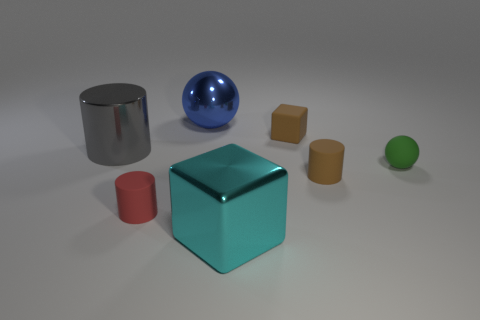How many other objects are the same size as the metallic cylinder?
Keep it short and to the point. 2. There is a tiny cylinder on the left side of the large thing that is behind the tiny object behind the tiny matte sphere; what is its material?
Provide a short and direct response. Rubber. Does the brown cube have the same material as the sphere that is behind the tiny green thing?
Your answer should be very brief. No. Are there fewer big blue things that are in front of the small green sphere than tiny green rubber things that are to the left of the tiny block?
Your answer should be very brief. No. How many big balls are the same material as the cyan cube?
Ensure brevity in your answer.  1. There is a rubber thing that is left of the block on the right side of the big shiny block; is there a shiny cylinder that is behind it?
Offer a very short reply. Yes. How many cylinders are either matte things or blue metal things?
Make the answer very short. 2. Does the red matte object have the same shape as the metal object left of the large blue thing?
Give a very brief answer. Yes. Are there fewer big balls left of the blue shiny thing than large shiny blocks?
Provide a short and direct response. Yes. There is a brown rubber cylinder; are there any matte cubes behind it?
Your answer should be very brief. Yes. 